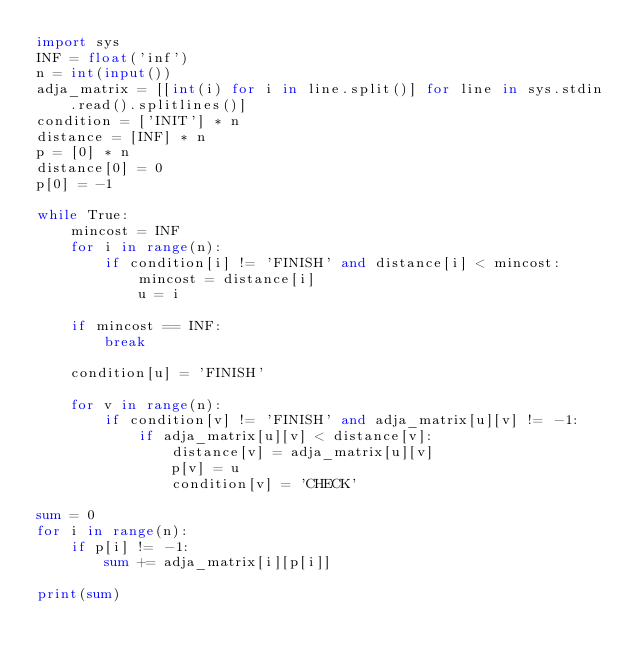<code> <loc_0><loc_0><loc_500><loc_500><_Python_>import sys
INF = float('inf')
n = int(input())
adja_matrix = [[int(i) for i in line.split()] for line in sys.stdin.read().splitlines()]
condition = ['INIT'] * n
distance = [INF] * n
p = [0] * n
distance[0] = 0
p[0] = -1

while True:
    mincost = INF
    for i in range(n):
        if condition[i] != 'FINISH' and distance[i] < mincost:
            mincost = distance[i]
            u = i

    if mincost == INF:
        break

    condition[u] = 'FINISH'

    for v in range(n):
        if condition[v] != 'FINISH' and adja_matrix[u][v] != -1:
            if adja_matrix[u][v] < distance[v]:
                distance[v] = adja_matrix[u][v]
                p[v] = u
                condition[v] = 'CHECK'

sum = 0
for i in range(n):
    if p[i] != -1:
        sum += adja_matrix[i][p[i]]

print(sum)
</code> 